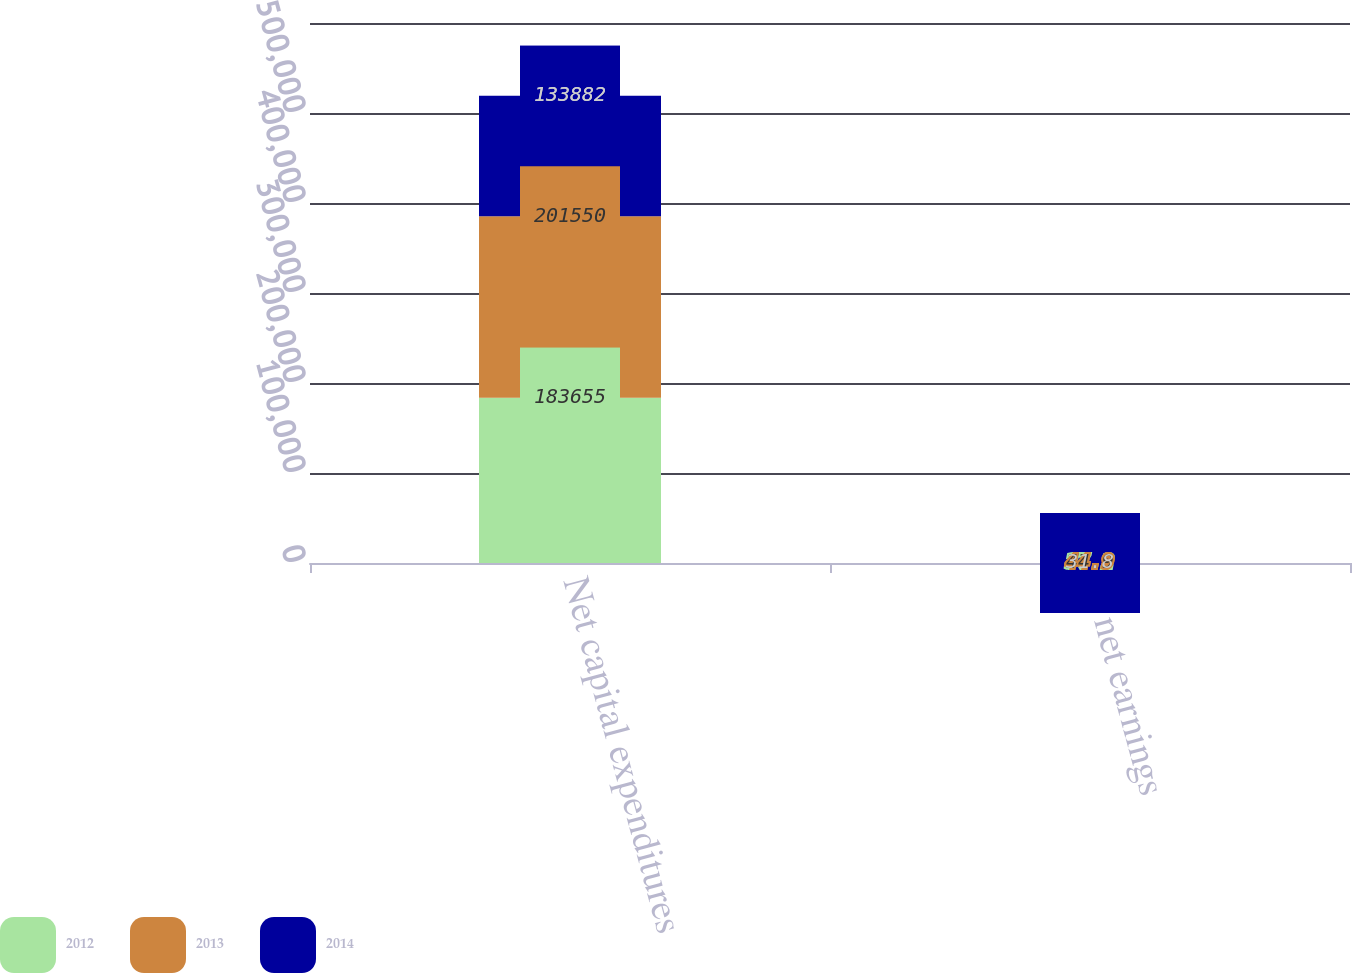Convert chart. <chart><loc_0><loc_0><loc_500><loc_500><stacked_bar_chart><ecel><fcel>Net capital expenditures<fcel>of net earnings<nl><fcel>2012<fcel>183655<fcel>37.2<nl><fcel>2013<fcel>201550<fcel>44.9<nl><fcel>2014<fcel>133882<fcel>31.8<nl></chart> 